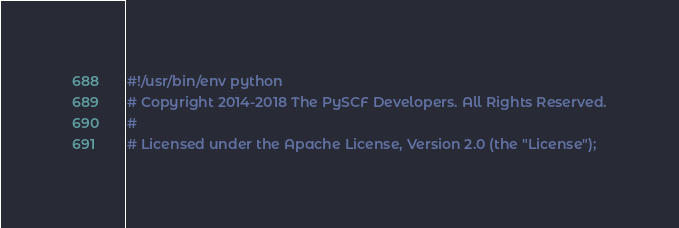Convert code to text. <code><loc_0><loc_0><loc_500><loc_500><_Python_>#!/usr/bin/env python
# Copyright 2014-2018 The PySCF Developers. All Rights Reserved.
#
# Licensed under the Apache License, Version 2.0 (the "License");</code> 